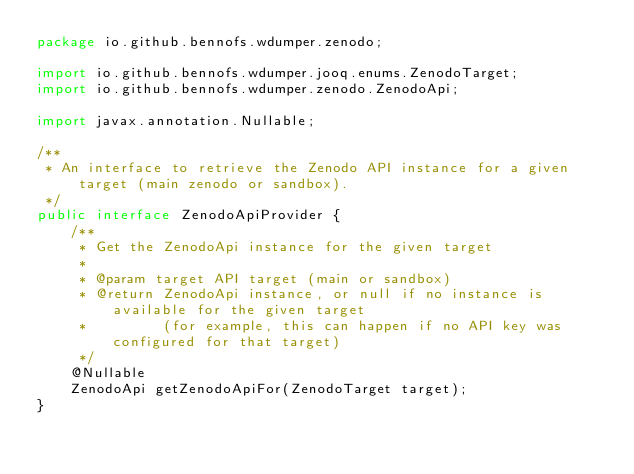Convert code to text. <code><loc_0><loc_0><loc_500><loc_500><_Java_>package io.github.bennofs.wdumper.zenodo;

import io.github.bennofs.wdumper.jooq.enums.ZenodoTarget;
import io.github.bennofs.wdumper.zenodo.ZenodoApi;

import javax.annotation.Nullable;

/**
 * An interface to retrieve the Zenodo API instance for a given target (main zenodo or sandbox).
 */
public interface ZenodoApiProvider {
    /**
     * Get the ZenodoApi instance for the given target
     *
     * @param target API target (main or sandbox)
     * @return ZenodoApi instance, or null if no instance is available for the given target
     *         (for example, this can happen if no API key was configured for that target)
     */
    @Nullable
    ZenodoApi getZenodoApiFor(ZenodoTarget target);
}
</code> 